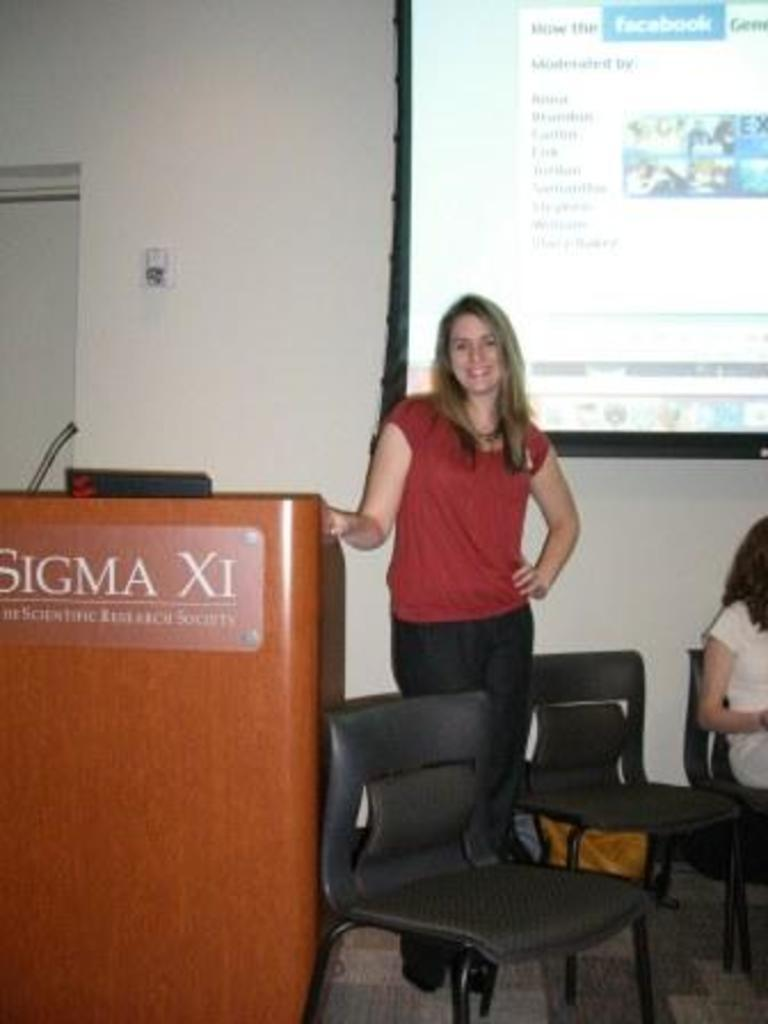What is the color of the wall in the image? The wall in the image is white. What can be seen on the wall in the image? There is a screen on the wall in the image. How many people are present in the image? There are two persons in the image. What type of furniture is visible in the image? There are two chairs in the image. What type of cracker is being used to respect the end of the meeting in the image? There is no meeting or cracker present in the image. What type of respect is being shown towards the end of the image? There is no indication of respect or an end in the image. 